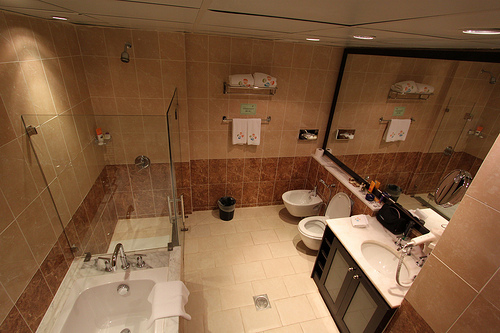Are there any items on the countertop, and if so, what are they? Yes, there are various items on the countertop including toiletries such as soap dispensers, hand towels, and personal care products which provide convenience and a touch of hospitality. 